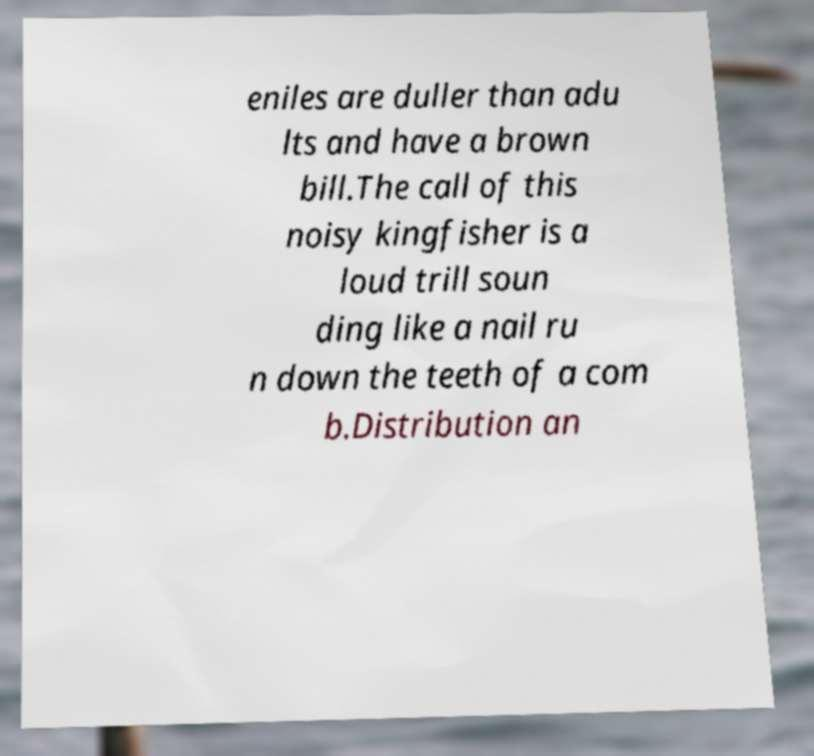Can you accurately transcribe the text from the provided image for me? eniles are duller than adu lts and have a brown bill.The call of this noisy kingfisher is a loud trill soun ding like a nail ru n down the teeth of a com b.Distribution an 